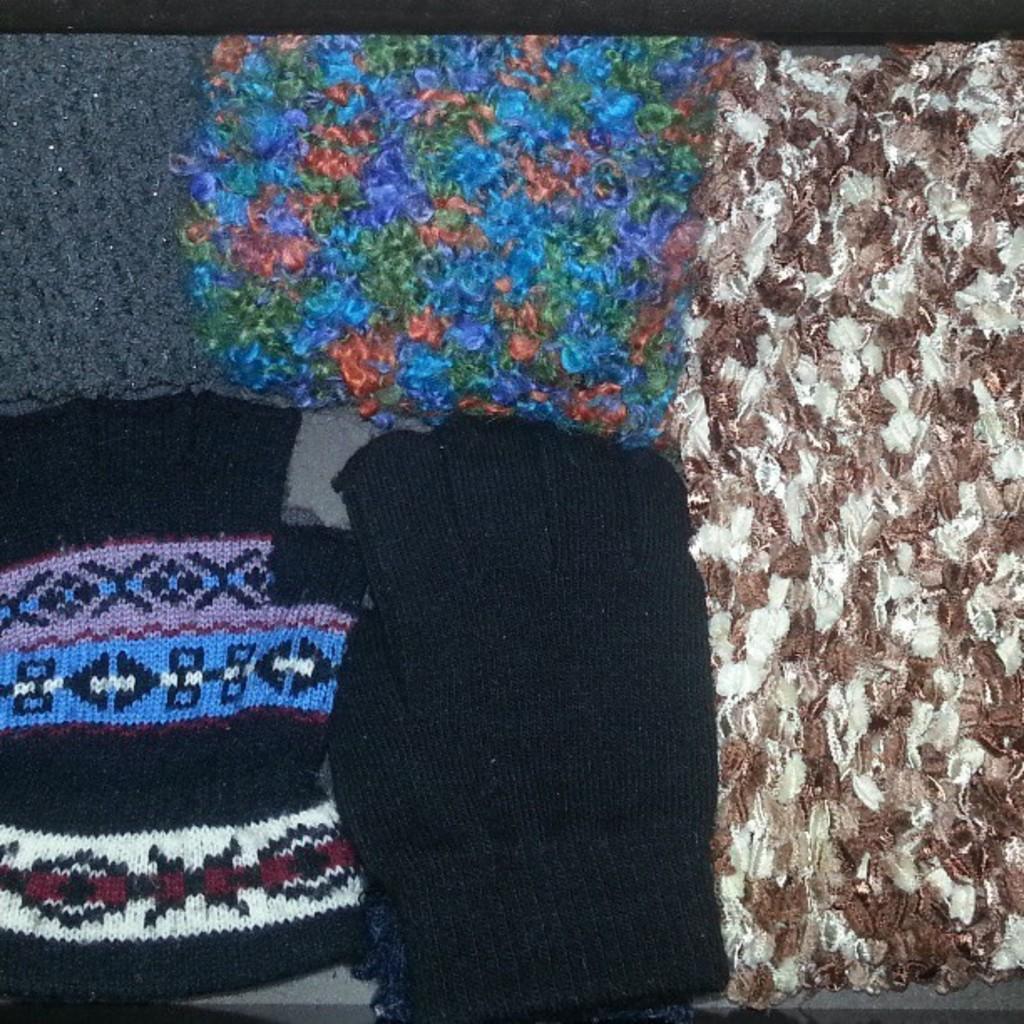How would you summarize this image in a sentence or two? In this picture they look like few woolen clothes. 